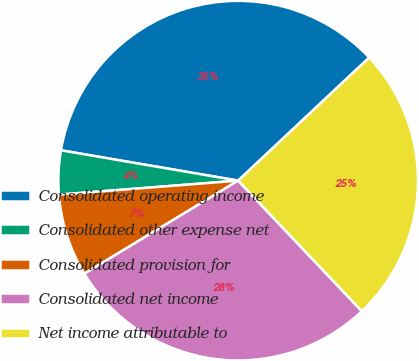Convert chart to OTSL. <chart><loc_0><loc_0><loc_500><loc_500><pie_chart><fcel>Consolidated operating income<fcel>Consolidated other expense net<fcel>Consolidated provision for<fcel>Consolidated net income<fcel>Net income attributable to<nl><fcel>35.3%<fcel>3.94%<fcel>7.42%<fcel>28.41%<fcel>24.93%<nl></chart> 